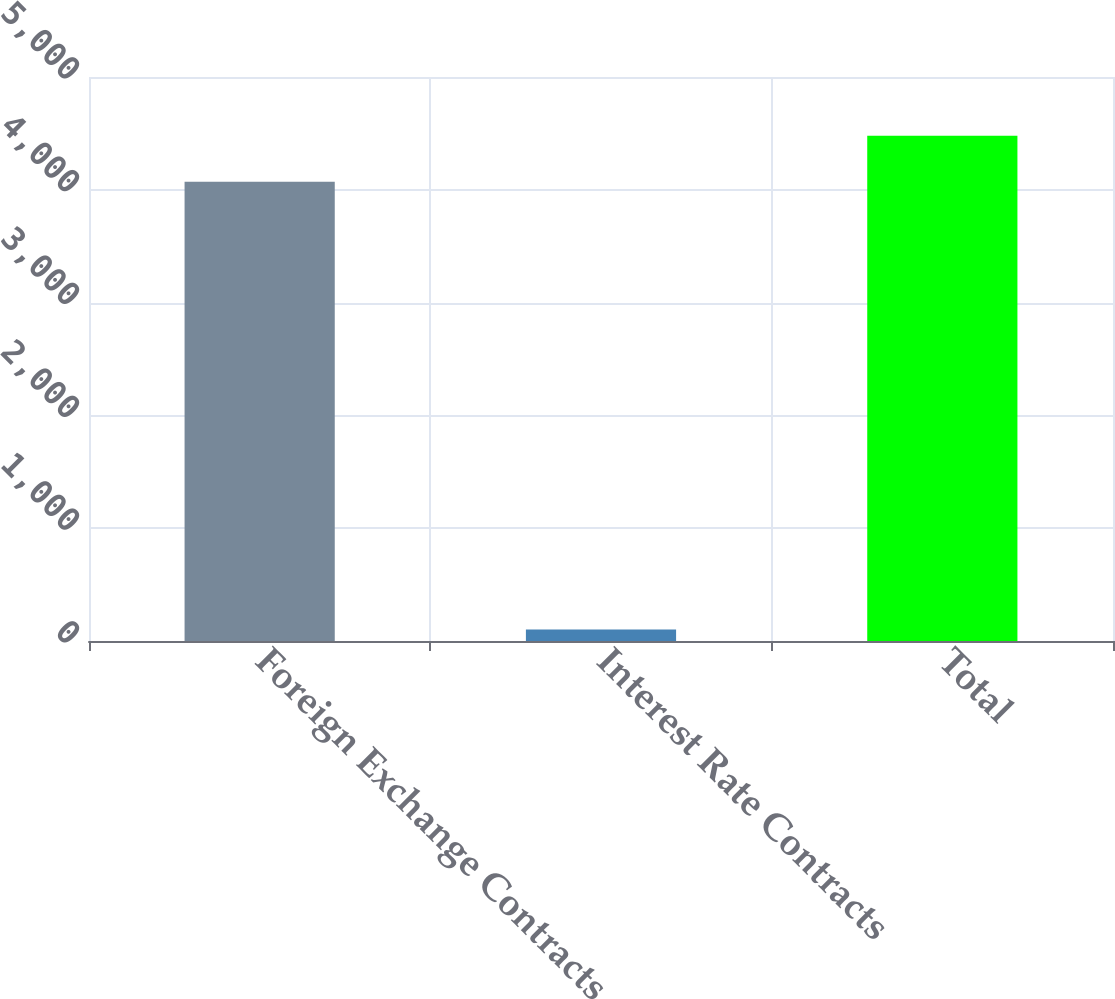Convert chart. <chart><loc_0><loc_0><loc_500><loc_500><bar_chart><fcel>Foreign Exchange Contracts<fcel>Interest Rate Contracts<fcel>Total<nl><fcel>4072<fcel>101.3<fcel>4479.2<nl></chart> 